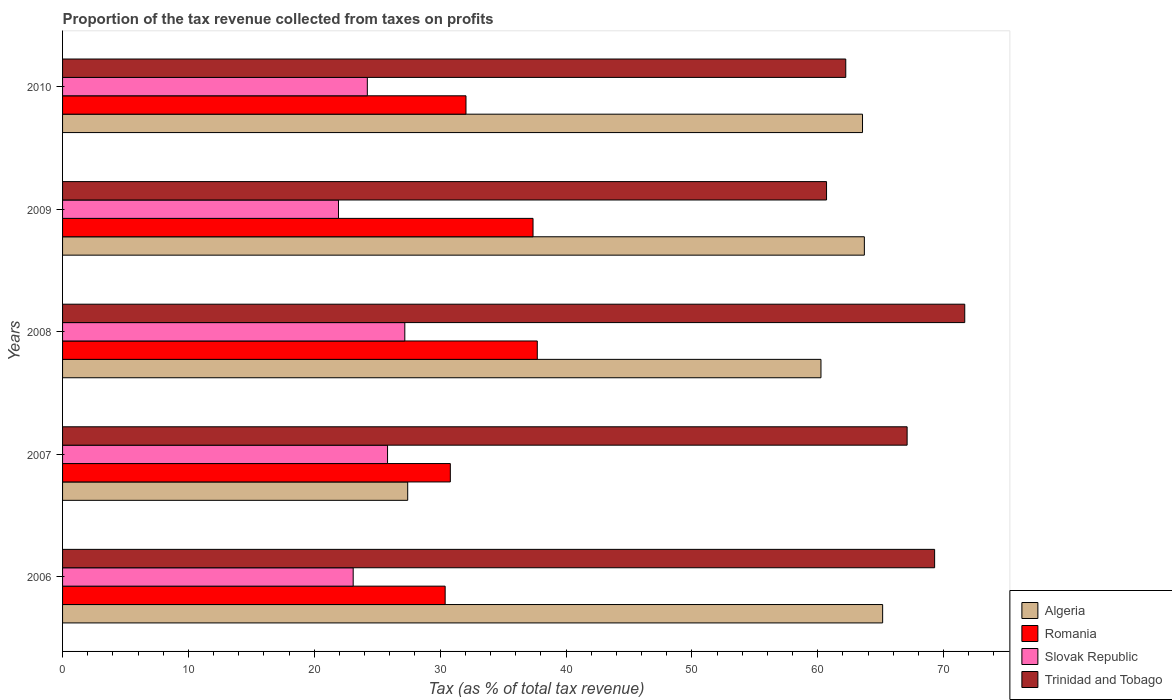How many different coloured bars are there?
Make the answer very short. 4. How many groups of bars are there?
Keep it short and to the point. 5. Are the number of bars per tick equal to the number of legend labels?
Your response must be concise. Yes. Are the number of bars on each tick of the Y-axis equal?
Your response must be concise. Yes. How many bars are there on the 5th tick from the top?
Your response must be concise. 4. What is the label of the 3rd group of bars from the top?
Ensure brevity in your answer.  2008. What is the proportion of the tax revenue collected in Algeria in 2009?
Provide a short and direct response. 63.71. Across all years, what is the maximum proportion of the tax revenue collected in Romania?
Ensure brevity in your answer.  37.72. Across all years, what is the minimum proportion of the tax revenue collected in Romania?
Keep it short and to the point. 30.4. In which year was the proportion of the tax revenue collected in Slovak Republic minimum?
Offer a terse response. 2009. What is the total proportion of the tax revenue collected in Romania in the graph?
Offer a very short reply. 168.36. What is the difference between the proportion of the tax revenue collected in Trinidad and Tobago in 2008 and that in 2009?
Provide a succinct answer. 10.98. What is the difference between the proportion of the tax revenue collected in Trinidad and Tobago in 2009 and the proportion of the tax revenue collected in Algeria in 2007?
Your answer should be very brief. 33.28. What is the average proportion of the tax revenue collected in Trinidad and Tobago per year?
Offer a very short reply. 66.2. In the year 2006, what is the difference between the proportion of the tax revenue collected in Romania and proportion of the tax revenue collected in Algeria?
Offer a terse response. -34.76. In how many years, is the proportion of the tax revenue collected in Slovak Republic greater than 30 %?
Keep it short and to the point. 0. What is the ratio of the proportion of the tax revenue collected in Romania in 2006 to that in 2008?
Offer a very short reply. 0.81. What is the difference between the highest and the second highest proportion of the tax revenue collected in Algeria?
Offer a terse response. 1.45. What is the difference between the highest and the lowest proportion of the tax revenue collected in Romania?
Your answer should be very brief. 7.32. Is the sum of the proportion of the tax revenue collected in Romania in 2007 and 2008 greater than the maximum proportion of the tax revenue collected in Algeria across all years?
Your response must be concise. Yes. What does the 2nd bar from the top in 2006 represents?
Provide a succinct answer. Slovak Republic. What does the 4th bar from the bottom in 2009 represents?
Your response must be concise. Trinidad and Tobago. How many bars are there?
Make the answer very short. 20. Are all the bars in the graph horizontal?
Keep it short and to the point. Yes. Are the values on the major ticks of X-axis written in scientific E-notation?
Offer a terse response. No. Does the graph contain any zero values?
Give a very brief answer. No. Where does the legend appear in the graph?
Your answer should be compact. Bottom right. How many legend labels are there?
Your answer should be compact. 4. How are the legend labels stacked?
Provide a short and direct response. Vertical. What is the title of the graph?
Provide a succinct answer. Proportion of the tax revenue collected from taxes on profits. Does "Peru" appear as one of the legend labels in the graph?
Provide a short and direct response. No. What is the label or title of the X-axis?
Your response must be concise. Tax (as % of total tax revenue). What is the label or title of the Y-axis?
Keep it short and to the point. Years. What is the Tax (as % of total tax revenue) in Algeria in 2006?
Ensure brevity in your answer.  65.16. What is the Tax (as % of total tax revenue) of Romania in 2006?
Offer a terse response. 30.4. What is the Tax (as % of total tax revenue) of Slovak Republic in 2006?
Give a very brief answer. 23.09. What is the Tax (as % of total tax revenue) in Trinidad and Tobago in 2006?
Give a very brief answer. 69.29. What is the Tax (as % of total tax revenue) in Algeria in 2007?
Provide a short and direct response. 27.42. What is the Tax (as % of total tax revenue) in Romania in 2007?
Your answer should be compact. 30.81. What is the Tax (as % of total tax revenue) of Slovak Republic in 2007?
Give a very brief answer. 25.82. What is the Tax (as % of total tax revenue) in Trinidad and Tobago in 2007?
Ensure brevity in your answer.  67.1. What is the Tax (as % of total tax revenue) of Algeria in 2008?
Provide a succinct answer. 60.26. What is the Tax (as % of total tax revenue) of Romania in 2008?
Ensure brevity in your answer.  37.72. What is the Tax (as % of total tax revenue) in Slovak Republic in 2008?
Your answer should be very brief. 27.19. What is the Tax (as % of total tax revenue) of Trinidad and Tobago in 2008?
Provide a succinct answer. 71.68. What is the Tax (as % of total tax revenue) of Algeria in 2009?
Keep it short and to the point. 63.71. What is the Tax (as % of total tax revenue) of Romania in 2009?
Give a very brief answer. 37.38. What is the Tax (as % of total tax revenue) of Slovak Republic in 2009?
Give a very brief answer. 21.92. What is the Tax (as % of total tax revenue) of Trinidad and Tobago in 2009?
Ensure brevity in your answer.  60.7. What is the Tax (as % of total tax revenue) of Algeria in 2010?
Keep it short and to the point. 63.56. What is the Tax (as % of total tax revenue) of Romania in 2010?
Offer a terse response. 32.05. What is the Tax (as % of total tax revenue) in Slovak Republic in 2010?
Provide a short and direct response. 24.21. What is the Tax (as % of total tax revenue) of Trinidad and Tobago in 2010?
Ensure brevity in your answer.  62.23. Across all years, what is the maximum Tax (as % of total tax revenue) in Algeria?
Give a very brief answer. 65.16. Across all years, what is the maximum Tax (as % of total tax revenue) in Romania?
Provide a succinct answer. 37.72. Across all years, what is the maximum Tax (as % of total tax revenue) of Slovak Republic?
Give a very brief answer. 27.19. Across all years, what is the maximum Tax (as % of total tax revenue) in Trinidad and Tobago?
Ensure brevity in your answer.  71.68. Across all years, what is the minimum Tax (as % of total tax revenue) of Algeria?
Provide a short and direct response. 27.42. Across all years, what is the minimum Tax (as % of total tax revenue) in Romania?
Provide a succinct answer. 30.4. Across all years, what is the minimum Tax (as % of total tax revenue) in Slovak Republic?
Provide a succinct answer. 21.92. Across all years, what is the minimum Tax (as % of total tax revenue) in Trinidad and Tobago?
Your answer should be very brief. 60.7. What is the total Tax (as % of total tax revenue) in Algeria in the graph?
Ensure brevity in your answer.  280.11. What is the total Tax (as % of total tax revenue) in Romania in the graph?
Provide a succinct answer. 168.36. What is the total Tax (as % of total tax revenue) in Slovak Republic in the graph?
Provide a succinct answer. 122.24. What is the total Tax (as % of total tax revenue) of Trinidad and Tobago in the graph?
Provide a succinct answer. 331.01. What is the difference between the Tax (as % of total tax revenue) of Algeria in 2006 and that in 2007?
Offer a terse response. 37.74. What is the difference between the Tax (as % of total tax revenue) of Romania in 2006 and that in 2007?
Make the answer very short. -0.41. What is the difference between the Tax (as % of total tax revenue) of Slovak Republic in 2006 and that in 2007?
Ensure brevity in your answer.  -2.73. What is the difference between the Tax (as % of total tax revenue) of Trinidad and Tobago in 2006 and that in 2007?
Your answer should be compact. 2.19. What is the difference between the Tax (as % of total tax revenue) of Algeria in 2006 and that in 2008?
Your response must be concise. 4.9. What is the difference between the Tax (as % of total tax revenue) in Romania in 2006 and that in 2008?
Provide a short and direct response. -7.32. What is the difference between the Tax (as % of total tax revenue) of Slovak Republic in 2006 and that in 2008?
Give a very brief answer. -4.1. What is the difference between the Tax (as % of total tax revenue) of Trinidad and Tobago in 2006 and that in 2008?
Provide a short and direct response. -2.39. What is the difference between the Tax (as % of total tax revenue) of Algeria in 2006 and that in 2009?
Keep it short and to the point. 1.45. What is the difference between the Tax (as % of total tax revenue) in Romania in 2006 and that in 2009?
Your answer should be compact. -6.98. What is the difference between the Tax (as % of total tax revenue) in Slovak Republic in 2006 and that in 2009?
Ensure brevity in your answer.  1.17. What is the difference between the Tax (as % of total tax revenue) of Trinidad and Tobago in 2006 and that in 2009?
Your answer should be compact. 8.59. What is the difference between the Tax (as % of total tax revenue) in Algeria in 2006 and that in 2010?
Provide a short and direct response. 1.6. What is the difference between the Tax (as % of total tax revenue) of Romania in 2006 and that in 2010?
Your answer should be compact. -1.65. What is the difference between the Tax (as % of total tax revenue) of Slovak Republic in 2006 and that in 2010?
Ensure brevity in your answer.  -1.12. What is the difference between the Tax (as % of total tax revenue) of Trinidad and Tobago in 2006 and that in 2010?
Give a very brief answer. 7.06. What is the difference between the Tax (as % of total tax revenue) in Algeria in 2007 and that in 2008?
Offer a very short reply. -32.84. What is the difference between the Tax (as % of total tax revenue) of Romania in 2007 and that in 2008?
Provide a succinct answer. -6.91. What is the difference between the Tax (as % of total tax revenue) in Slovak Republic in 2007 and that in 2008?
Offer a terse response. -1.37. What is the difference between the Tax (as % of total tax revenue) of Trinidad and Tobago in 2007 and that in 2008?
Provide a short and direct response. -4.58. What is the difference between the Tax (as % of total tax revenue) in Algeria in 2007 and that in 2009?
Keep it short and to the point. -36.28. What is the difference between the Tax (as % of total tax revenue) of Romania in 2007 and that in 2009?
Provide a succinct answer. -6.57. What is the difference between the Tax (as % of total tax revenue) in Slovak Republic in 2007 and that in 2009?
Offer a terse response. 3.9. What is the difference between the Tax (as % of total tax revenue) of Trinidad and Tobago in 2007 and that in 2009?
Your answer should be very brief. 6.4. What is the difference between the Tax (as % of total tax revenue) of Algeria in 2007 and that in 2010?
Offer a terse response. -36.14. What is the difference between the Tax (as % of total tax revenue) of Romania in 2007 and that in 2010?
Provide a short and direct response. -1.24. What is the difference between the Tax (as % of total tax revenue) in Slovak Republic in 2007 and that in 2010?
Your answer should be very brief. 1.61. What is the difference between the Tax (as % of total tax revenue) in Trinidad and Tobago in 2007 and that in 2010?
Offer a very short reply. 4.88. What is the difference between the Tax (as % of total tax revenue) of Algeria in 2008 and that in 2009?
Offer a terse response. -3.45. What is the difference between the Tax (as % of total tax revenue) in Romania in 2008 and that in 2009?
Make the answer very short. 0.34. What is the difference between the Tax (as % of total tax revenue) in Slovak Republic in 2008 and that in 2009?
Provide a short and direct response. 5.27. What is the difference between the Tax (as % of total tax revenue) in Trinidad and Tobago in 2008 and that in 2009?
Ensure brevity in your answer.  10.98. What is the difference between the Tax (as % of total tax revenue) in Algeria in 2008 and that in 2010?
Your answer should be very brief. -3.3. What is the difference between the Tax (as % of total tax revenue) of Romania in 2008 and that in 2010?
Your answer should be very brief. 5.67. What is the difference between the Tax (as % of total tax revenue) of Slovak Republic in 2008 and that in 2010?
Give a very brief answer. 2.98. What is the difference between the Tax (as % of total tax revenue) in Trinidad and Tobago in 2008 and that in 2010?
Make the answer very short. 9.45. What is the difference between the Tax (as % of total tax revenue) of Algeria in 2009 and that in 2010?
Your answer should be compact. 0.15. What is the difference between the Tax (as % of total tax revenue) of Romania in 2009 and that in 2010?
Provide a succinct answer. 5.33. What is the difference between the Tax (as % of total tax revenue) of Slovak Republic in 2009 and that in 2010?
Provide a short and direct response. -2.29. What is the difference between the Tax (as % of total tax revenue) in Trinidad and Tobago in 2009 and that in 2010?
Give a very brief answer. -1.53. What is the difference between the Tax (as % of total tax revenue) in Algeria in 2006 and the Tax (as % of total tax revenue) in Romania in 2007?
Make the answer very short. 34.35. What is the difference between the Tax (as % of total tax revenue) in Algeria in 2006 and the Tax (as % of total tax revenue) in Slovak Republic in 2007?
Keep it short and to the point. 39.34. What is the difference between the Tax (as % of total tax revenue) in Algeria in 2006 and the Tax (as % of total tax revenue) in Trinidad and Tobago in 2007?
Ensure brevity in your answer.  -1.95. What is the difference between the Tax (as % of total tax revenue) of Romania in 2006 and the Tax (as % of total tax revenue) of Slovak Republic in 2007?
Provide a succinct answer. 4.58. What is the difference between the Tax (as % of total tax revenue) of Romania in 2006 and the Tax (as % of total tax revenue) of Trinidad and Tobago in 2007?
Your response must be concise. -36.71. What is the difference between the Tax (as % of total tax revenue) of Slovak Republic in 2006 and the Tax (as % of total tax revenue) of Trinidad and Tobago in 2007?
Give a very brief answer. -44.01. What is the difference between the Tax (as % of total tax revenue) in Algeria in 2006 and the Tax (as % of total tax revenue) in Romania in 2008?
Offer a terse response. 27.44. What is the difference between the Tax (as % of total tax revenue) of Algeria in 2006 and the Tax (as % of total tax revenue) of Slovak Republic in 2008?
Your answer should be compact. 37.97. What is the difference between the Tax (as % of total tax revenue) in Algeria in 2006 and the Tax (as % of total tax revenue) in Trinidad and Tobago in 2008?
Keep it short and to the point. -6.52. What is the difference between the Tax (as % of total tax revenue) in Romania in 2006 and the Tax (as % of total tax revenue) in Slovak Republic in 2008?
Offer a very short reply. 3.21. What is the difference between the Tax (as % of total tax revenue) in Romania in 2006 and the Tax (as % of total tax revenue) in Trinidad and Tobago in 2008?
Offer a terse response. -41.28. What is the difference between the Tax (as % of total tax revenue) of Slovak Republic in 2006 and the Tax (as % of total tax revenue) of Trinidad and Tobago in 2008?
Your response must be concise. -48.59. What is the difference between the Tax (as % of total tax revenue) in Algeria in 2006 and the Tax (as % of total tax revenue) in Romania in 2009?
Offer a very short reply. 27.78. What is the difference between the Tax (as % of total tax revenue) of Algeria in 2006 and the Tax (as % of total tax revenue) of Slovak Republic in 2009?
Offer a terse response. 43.24. What is the difference between the Tax (as % of total tax revenue) in Algeria in 2006 and the Tax (as % of total tax revenue) in Trinidad and Tobago in 2009?
Offer a very short reply. 4.46. What is the difference between the Tax (as % of total tax revenue) of Romania in 2006 and the Tax (as % of total tax revenue) of Slovak Republic in 2009?
Ensure brevity in your answer.  8.48. What is the difference between the Tax (as % of total tax revenue) in Romania in 2006 and the Tax (as % of total tax revenue) in Trinidad and Tobago in 2009?
Your response must be concise. -30.3. What is the difference between the Tax (as % of total tax revenue) in Slovak Republic in 2006 and the Tax (as % of total tax revenue) in Trinidad and Tobago in 2009?
Offer a terse response. -37.61. What is the difference between the Tax (as % of total tax revenue) in Algeria in 2006 and the Tax (as % of total tax revenue) in Romania in 2010?
Give a very brief answer. 33.11. What is the difference between the Tax (as % of total tax revenue) of Algeria in 2006 and the Tax (as % of total tax revenue) of Slovak Republic in 2010?
Your answer should be very brief. 40.94. What is the difference between the Tax (as % of total tax revenue) of Algeria in 2006 and the Tax (as % of total tax revenue) of Trinidad and Tobago in 2010?
Your response must be concise. 2.93. What is the difference between the Tax (as % of total tax revenue) in Romania in 2006 and the Tax (as % of total tax revenue) in Slovak Republic in 2010?
Offer a very short reply. 6.18. What is the difference between the Tax (as % of total tax revenue) of Romania in 2006 and the Tax (as % of total tax revenue) of Trinidad and Tobago in 2010?
Your response must be concise. -31.83. What is the difference between the Tax (as % of total tax revenue) of Slovak Republic in 2006 and the Tax (as % of total tax revenue) of Trinidad and Tobago in 2010?
Offer a terse response. -39.14. What is the difference between the Tax (as % of total tax revenue) in Algeria in 2007 and the Tax (as % of total tax revenue) in Romania in 2008?
Your answer should be compact. -10.3. What is the difference between the Tax (as % of total tax revenue) in Algeria in 2007 and the Tax (as % of total tax revenue) in Slovak Republic in 2008?
Give a very brief answer. 0.23. What is the difference between the Tax (as % of total tax revenue) of Algeria in 2007 and the Tax (as % of total tax revenue) of Trinidad and Tobago in 2008?
Offer a very short reply. -44.26. What is the difference between the Tax (as % of total tax revenue) in Romania in 2007 and the Tax (as % of total tax revenue) in Slovak Republic in 2008?
Keep it short and to the point. 3.62. What is the difference between the Tax (as % of total tax revenue) of Romania in 2007 and the Tax (as % of total tax revenue) of Trinidad and Tobago in 2008?
Offer a terse response. -40.87. What is the difference between the Tax (as % of total tax revenue) in Slovak Republic in 2007 and the Tax (as % of total tax revenue) in Trinidad and Tobago in 2008?
Your answer should be very brief. -45.86. What is the difference between the Tax (as % of total tax revenue) of Algeria in 2007 and the Tax (as % of total tax revenue) of Romania in 2009?
Provide a short and direct response. -9.96. What is the difference between the Tax (as % of total tax revenue) of Algeria in 2007 and the Tax (as % of total tax revenue) of Slovak Republic in 2009?
Keep it short and to the point. 5.5. What is the difference between the Tax (as % of total tax revenue) of Algeria in 2007 and the Tax (as % of total tax revenue) of Trinidad and Tobago in 2009?
Ensure brevity in your answer.  -33.28. What is the difference between the Tax (as % of total tax revenue) of Romania in 2007 and the Tax (as % of total tax revenue) of Slovak Republic in 2009?
Provide a short and direct response. 8.89. What is the difference between the Tax (as % of total tax revenue) in Romania in 2007 and the Tax (as % of total tax revenue) in Trinidad and Tobago in 2009?
Offer a very short reply. -29.89. What is the difference between the Tax (as % of total tax revenue) of Slovak Republic in 2007 and the Tax (as % of total tax revenue) of Trinidad and Tobago in 2009?
Your answer should be compact. -34.88. What is the difference between the Tax (as % of total tax revenue) in Algeria in 2007 and the Tax (as % of total tax revenue) in Romania in 2010?
Your response must be concise. -4.63. What is the difference between the Tax (as % of total tax revenue) of Algeria in 2007 and the Tax (as % of total tax revenue) of Slovak Republic in 2010?
Provide a succinct answer. 3.21. What is the difference between the Tax (as % of total tax revenue) of Algeria in 2007 and the Tax (as % of total tax revenue) of Trinidad and Tobago in 2010?
Give a very brief answer. -34.81. What is the difference between the Tax (as % of total tax revenue) of Romania in 2007 and the Tax (as % of total tax revenue) of Slovak Republic in 2010?
Keep it short and to the point. 6.59. What is the difference between the Tax (as % of total tax revenue) of Romania in 2007 and the Tax (as % of total tax revenue) of Trinidad and Tobago in 2010?
Your response must be concise. -31.42. What is the difference between the Tax (as % of total tax revenue) of Slovak Republic in 2007 and the Tax (as % of total tax revenue) of Trinidad and Tobago in 2010?
Offer a terse response. -36.41. What is the difference between the Tax (as % of total tax revenue) in Algeria in 2008 and the Tax (as % of total tax revenue) in Romania in 2009?
Provide a succinct answer. 22.88. What is the difference between the Tax (as % of total tax revenue) of Algeria in 2008 and the Tax (as % of total tax revenue) of Slovak Republic in 2009?
Provide a succinct answer. 38.34. What is the difference between the Tax (as % of total tax revenue) of Algeria in 2008 and the Tax (as % of total tax revenue) of Trinidad and Tobago in 2009?
Your answer should be very brief. -0.44. What is the difference between the Tax (as % of total tax revenue) in Romania in 2008 and the Tax (as % of total tax revenue) in Slovak Republic in 2009?
Your answer should be compact. 15.8. What is the difference between the Tax (as % of total tax revenue) of Romania in 2008 and the Tax (as % of total tax revenue) of Trinidad and Tobago in 2009?
Give a very brief answer. -22.98. What is the difference between the Tax (as % of total tax revenue) in Slovak Republic in 2008 and the Tax (as % of total tax revenue) in Trinidad and Tobago in 2009?
Make the answer very short. -33.51. What is the difference between the Tax (as % of total tax revenue) of Algeria in 2008 and the Tax (as % of total tax revenue) of Romania in 2010?
Your response must be concise. 28.21. What is the difference between the Tax (as % of total tax revenue) in Algeria in 2008 and the Tax (as % of total tax revenue) in Slovak Republic in 2010?
Offer a terse response. 36.04. What is the difference between the Tax (as % of total tax revenue) in Algeria in 2008 and the Tax (as % of total tax revenue) in Trinidad and Tobago in 2010?
Your response must be concise. -1.97. What is the difference between the Tax (as % of total tax revenue) of Romania in 2008 and the Tax (as % of total tax revenue) of Slovak Republic in 2010?
Your answer should be very brief. 13.51. What is the difference between the Tax (as % of total tax revenue) in Romania in 2008 and the Tax (as % of total tax revenue) in Trinidad and Tobago in 2010?
Give a very brief answer. -24.51. What is the difference between the Tax (as % of total tax revenue) of Slovak Republic in 2008 and the Tax (as % of total tax revenue) of Trinidad and Tobago in 2010?
Make the answer very short. -35.04. What is the difference between the Tax (as % of total tax revenue) of Algeria in 2009 and the Tax (as % of total tax revenue) of Romania in 2010?
Your answer should be compact. 31.65. What is the difference between the Tax (as % of total tax revenue) in Algeria in 2009 and the Tax (as % of total tax revenue) in Slovak Republic in 2010?
Offer a terse response. 39.49. What is the difference between the Tax (as % of total tax revenue) in Algeria in 2009 and the Tax (as % of total tax revenue) in Trinidad and Tobago in 2010?
Offer a terse response. 1.48. What is the difference between the Tax (as % of total tax revenue) of Romania in 2009 and the Tax (as % of total tax revenue) of Slovak Republic in 2010?
Provide a succinct answer. 13.17. What is the difference between the Tax (as % of total tax revenue) in Romania in 2009 and the Tax (as % of total tax revenue) in Trinidad and Tobago in 2010?
Your response must be concise. -24.85. What is the difference between the Tax (as % of total tax revenue) in Slovak Republic in 2009 and the Tax (as % of total tax revenue) in Trinidad and Tobago in 2010?
Offer a very short reply. -40.31. What is the average Tax (as % of total tax revenue) in Algeria per year?
Offer a terse response. 56.02. What is the average Tax (as % of total tax revenue) in Romania per year?
Provide a short and direct response. 33.67. What is the average Tax (as % of total tax revenue) of Slovak Republic per year?
Give a very brief answer. 24.45. What is the average Tax (as % of total tax revenue) in Trinidad and Tobago per year?
Your answer should be compact. 66.2. In the year 2006, what is the difference between the Tax (as % of total tax revenue) of Algeria and Tax (as % of total tax revenue) of Romania?
Keep it short and to the point. 34.76. In the year 2006, what is the difference between the Tax (as % of total tax revenue) in Algeria and Tax (as % of total tax revenue) in Slovak Republic?
Offer a very short reply. 42.07. In the year 2006, what is the difference between the Tax (as % of total tax revenue) of Algeria and Tax (as % of total tax revenue) of Trinidad and Tobago?
Your answer should be compact. -4.13. In the year 2006, what is the difference between the Tax (as % of total tax revenue) in Romania and Tax (as % of total tax revenue) in Slovak Republic?
Your response must be concise. 7.31. In the year 2006, what is the difference between the Tax (as % of total tax revenue) in Romania and Tax (as % of total tax revenue) in Trinidad and Tobago?
Give a very brief answer. -38.89. In the year 2006, what is the difference between the Tax (as % of total tax revenue) of Slovak Republic and Tax (as % of total tax revenue) of Trinidad and Tobago?
Give a very brief answer. -46.2. In the year 2007, what is the difference between the Tax (as % of total tax revenue) in Algeria and Tax (as % of total tax revenue) in Romania?
Your response must be concise. -3.39. In the year 2007, what is the difference between the Tax (as % of total tax revenue) in Algeria and Tax (as % of total tax revenue) in Slovak Republic?
Your answer should be very brief. 1.6. In the year 2007, what is the difference between the Tax (as % of total tax revenue) in Algeria and Tax (as % of total tax revenue) in Trinidad and Tobago?
Your response must be concise. -39.68. In the year 2007, what is the difference between the Tax (as % of total tax revenue) in Romania and Tax (as % of total tax revenue) in Slovak Republic?
Ensure brevity in your answer.  4.99. In the year 2007, what is the difference between the Tax (as % of total tax revenue) of Romania and Tax (as % of total tax revenue) of Trinidad and Tobago?
Give a very brief answer. -36.3. In the year 2007, what is the difference between the Tax (as % of total tax revenue) in Slovak Republic and Tax (as % of total tax revenue) in Trinidad and Tobago?
Provide a succinct answer. -41.28. In the year 2008, what is the difference between the Tax (as % of total tax revenue) in Algeria and Tax (as % of total tax revenue) in Romania?
Ensure brevity in your answer.  22.54. In the year 2008, what is the difference between the Tax (as % of total tax revenue) of Algeria and Tax (as % of total tax revenue) of Slovak Republic?
Make the answer very short. 33.07. In the year 2008, what is the difference between the Tax (as % of total tax revenue) in Algeria and Tax (as % of total tax revenue) in Trinidad and Tobago?
Your answer should be very brief. -11.42. In the year 2008, what is the difference between the Tax (as % of total tax revenue) of Romania and Tax (as % of total tax revenue) of Slovak Republic?
Offer a terse response. 10.53. In the year 2008, what is the difference between the Tax (as % of total tax revenue) in Romania and Tax (as % of total tax revenue) in Trinidad and Tobago?
Offer a very short reply. -33.96. In the year 2008, what is the difference between the Tax (as % of total tax revenue) of Slovak Republic and Tax (as % of total tax revenue) of Trinidad and Tobago?
Provide a short and direct response. -44.49. In the year 2009, what is the difference between the Tax (as % of total tax revenue) of Algeria and Tax (as % of total tax revenue) of Romania?
Your answer should be very brief. 26.33. In the year 2009, what is the difference between the Tax (as % of total tax revenue) in Algeria and Tax (as % of total tax revenue) in Slovak Republic?
Your response must be concise. 41.78. In the year 2009, what is the difference between the Tax (as % of total tax revenue) in Algeria and Tax (as % of total tax revenue) in Trinidad and Tobago?
Make the answer very short. 3. In the year 2009, what is the difference between the Tax (as % of total tax revenue) of Romania and Tax (as % of total tax revenue) of Slovak Republic?
Your answer should be very brief. 15.46. In the year 2009, what is the difference between the Tax (as % of total tax revenue) in Romania and Tax (as % of total tax revenue) in Trinidad and Tobago?
Keep it short and to the point. -23.32. In the year 2009, what is the difference between the Tax (as % of total tax revenue) of Slovak Republic and Tax (as % of total tax revenue) of Trinidad and Tobago?
Your answer should be very brief. -38.78. In the year 2010, what is the difference between the Tax (as % of total tax revenue) of Algeria and Tax (as % of total tax revenue) of Romania?
Provide a succinct answer. 31.51. In the year 2010, what is the difference between the Tax (as % of total tax revenue) in Algeria and Tax (as % of total tax revenue) in Slovak Republic?
Your response must be concise. 39.34. In the year 2010, what is the difference between the Tax (as % of total tax revenue) in Algeria and Tax (as % of total tax revenue) in Trinidad and Tobago?
Keep it short and to the point. 1.33. In the year 2010, what is the difference between the Tax (as % of total tax revenue) of Romania and Tax (as % of total tax revenue) of Slovak Republic?
Offer a terse response. 7.84. In the year 2010, what is the difference between the Tax (as % of total tax revenue) in Romania and Tax (as % of total tax revenue) in Trinidad and Tobago?
Your answer should be compact. -30.18. In the year 2010, what is the difference between the Tax (as % of total tax revenue) in Slovak Republic and Tax (as % of total tax revenue) in Trinidad and Tobago?
Ensure brevity in your answer.  -38.01. What is the ratio of the Tax (as % of total tax revenue) of Algeria in 2006 to that in 2007?
Offer a very short reply. 2.38. What is the ratio of the Tax (as % of total tax revenue) of Romania in 2006 to that in 2007?
Make the answer very short. 0.99. What is the ratio of the Tax (as % of total tax revenue) in Slovak Republic in 2006 to that in 2007?
Provide a succinct answer. 0.89. What is the ratio of the Tax (as % of total tax revenue) of Trinidad and Tobago in 2006 to that in 2007?
Give a very brief answer. 1.03. What is the ratio of the Tax (as % of total tax revenue) of Algeria in 2006 to that in 2008?
Make the answer very short. 1.08. What is the ratio of the Tax (as % of total tax revenue) of Romania in 2006 to that in 2008?
Offer a terse response. 0.81. What is the ratio of the Tax (as % of total tax revenue) of Slovak Republic in 2006 to that in 2008?
Make the answer very short. 0.85. What is the ratio of the Tax (as % of total tax revenue) of Trinidad and Tobago in 2006 to that in 2008?
Provide a succinct answer. 0.97. What is the ratio of the Tax (as % of total tax revenue) of Algeria in 2006 to that in 2009?
Keep it short and to the point. 1.02. What is the ratio of the Tax (as % of total tax revenue) of Romania in 2006 to that in 2009?
Your answer should be very brief. 0.81. What is the ratio of the Tax (as % of total tax revenue) of Slovak Republic in 2006 to that in 2009?
Offer a very short reply. 1.05. What is the ratio of the Tax (as % of total tax revenue) in Trinidad and Tobago in 2006 to that in 2009?
Provide a succinct answer. 1.14. What is the ratio of the Tax (as % of total tax revenue) in Algeria in 2006 to that in 2010?
Provide a succinct answer. 1.03. What is the ratio of the Tax (as % of total tax revenue) of Romania in 2006 to that in 2010?
Your answer should be very brief. 0.95. What is the ratio of the Tax (as % of total tax revenue) in Slovak Republic in 2006 to that in 2010?
Provide a succinct answer. 0.95. What is the ratio of the Tax (as % of total tax revenue) in Trinidad and Tobago in 2006 to that in 2010?
Make the answer very short. 1.11. What is the ratio of the Tax (as % of total tax revenue) in Algeria in 2007 to that in 2008?
Give a very brief answer. 0.46. What is the ratio of the Tax (as % of total tax revenue) of Romania in 2007 to that in 2008?
Your answer should be compact. 0.82. What is the ratio of the Tax (as % of total tax revenue) in Slovak Republic in 2007 to that in 2008?
Your answer should be compact. 0.95. What is the ratio of the Tax (as % of total tax revenue) of Trinidad and Tobago in 2007 to that in 2008?
Ensure brevity in your answer.  0.94. What is the ratio of the Tax (as % of total tax revenue) of Algeria in 2007 to that in 2009?
Ensure brevity in your answer.  0.43. What is the ratio of the Tax (as % of total tax revenue) in Romania in 2007 to that in 2009?
Make the answer very short. 0.82. What is the ratio of the Tax (as % of total tax revenue) of Slovak Republic in 2007 to that in 2009?
Offer a very short reply. 1.18. What is the ratio of the Tax (as % of total tax revenue) in Trinidad and Tobago in 2007 to that in 2009?
Offer a very short reply. 1.11. What is the ratio of the Tax (as % of total tax revenue) in Algeria in 2007 to that in 2010?
Your answer should be very brief. 0.43. What is the ratio of the Tax (as % of total tax revenue) in Romania in 2007 to that in 2010?
Your response must be concise. 0.96. What is the ratio of the Tax (as % of total tax revenue) in Slovak Republic in 2007 to that in 2010?
Make the answer very short. 1.07. What is the ratio of the Tax (as % of total tax revenue) in Trinidad and Tobago in 2007 to that in 2010?
Provide a succinct answer. 1.08. What is the ratio of the Tax (as % of total tax revenue) of Algeria in 2008 to that in 2009?
Offer a terse response. 0.95. What is the ratio of the Tax (as % of total tax revenue) of Romania in 2008 to that in 2009?
Provide a short and direct response. 1.01. What is the ratio of the Tax (as % of total tax revenue) of Slovak Republic in 2008 to that in 2009?
Your answer should be compact. 1.24. What is the ratio of the Tax (as % of total tax revenue) of Trinidad and Tobago in 2008 to that in 2009?
Offer a very short reply. 1.18. What is the ratio of the Tax (as % of total tax revenue) in Algeria in 2008 to that in 2010?
Ensure brevity in your answer.  0.95. What is the ratio of the Tax (as % of total tax revenue) in Romania in 2008 to that in 2010?
Your answer should be compact. 1.18. What is the ratio of the Tax (as % of total tax revenue) of Slovak Republic in 2008 to that in 2010?
Your answer should be compact. 1.12. What is the ratio of the Tax (as % of total tax revenue) of Trinidad and Tobago in 2008 to that in 2010?
Ensure brevity in your answer.  1.15. What is the ratio of the Tax (as % of total tax revenue) in Romania in 2009 to that in 2010?
Provide a short and direct response. 1.17. What is the ratio of the Tax (as % of total tax revenue) of Slovak Republic in 2009 to that in 2010?
Ensure brevity in your answer.  0.91. What is the ratio of the Tax (as % of total tax revenue) of Trinidad and Tobago in 2009 to that in 2010?
Provide a succinct answer. 0.98. What is the difference between the highest and the second highest Tax (as % of total tax revenue) in Algeria?
Keep it short and to the point. 1.45. What is the difference between the highest and the second highest Tax (as % of total tax revenue) of Romania?
Your response must be concise. 0.34. What is the difference between the highest and the second highest Tax (as % of total tax revenue) in Slovak Republic?
Offer a terse response. 1.37. What is the difference between the highest and the second highest Tax (as % of total tax revenue) of Trinidad and Tobago?
Your response must be concise. 2.39. What is the difference between the highest and the lowest Tax (as % of total tax revenue) in Algeria?
Give a very brief answer. 37.74. What is the difference between the highest and the lowest Tax (as % of total tax revenue) of Romania?
Ensure brevity in your answer.  7.32. What is the difference between the highest and the lowest Tax (as % of total tax revenue) in Slovak Republic?
Your answer should be compact. 5.27. What is the difference between the highest and the lowest Tax (as % of total tax revenue) of Trinidad and Tobago?
Make the answer very short. 10.98. 